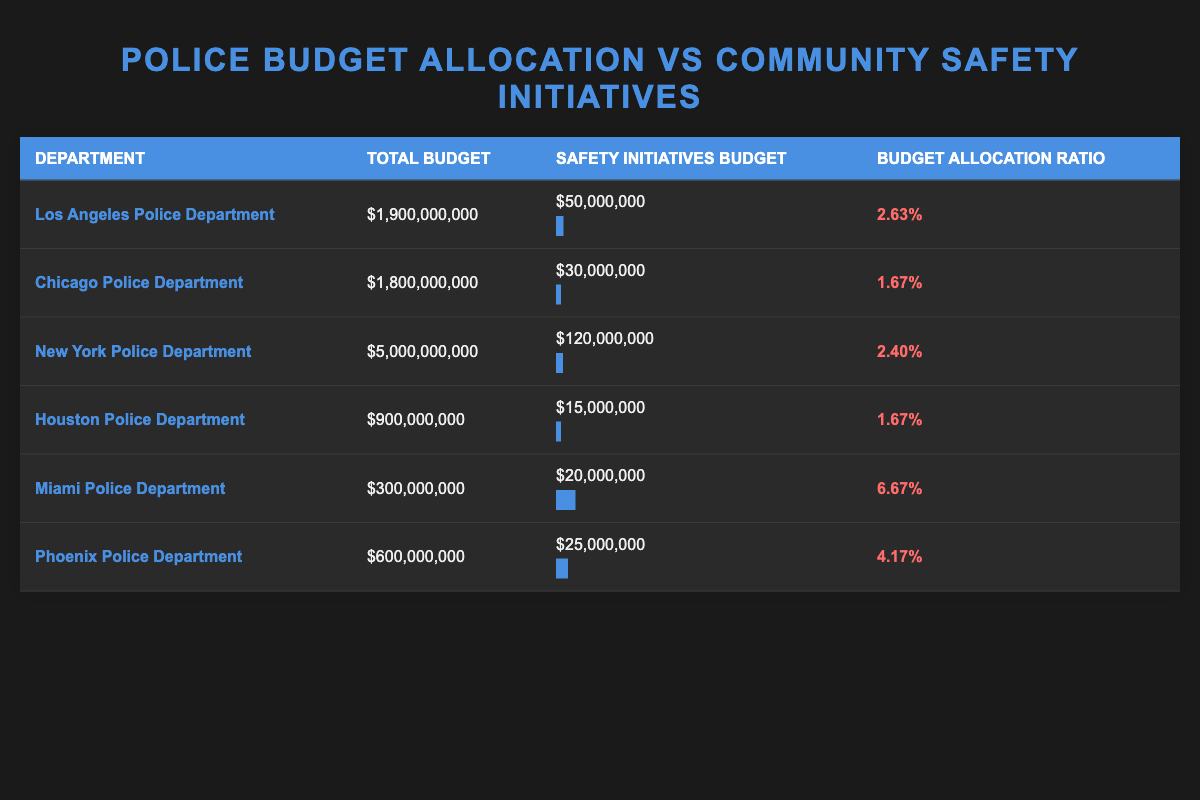What is the total budget for the New York Police Department? The total budget is listed directly in the table under the 'Total Budget' column for the New York Police Department. It shows $5,000,000,000.
Answer: 5,000,000,000 Which police department has the highest budget allocation ratio for safety initiatives? By examining the 'Budget Allocation Ratio' column, the Miami Police Department has the highest value at 6.67%.
Answer: 6.67% Is the safety initiatives budget for the Houston Police Department higher than the Chicago Police Department? Comparing the safety initiatives budget from both departments: Houston has $15,000,000 while Chicago has $30,000,000. Since $15,000,000 is less than $30,000,000, the answer is no.
Answer: No What is the combined total budget for the Los Angeles and Phoenix Police Departments? The total budget for Los Angeles is $1,900,000,000 and for Phoenix it is $600,000,000. Adding these together gives $1,900,000,000 + $600,000,000 = $2,500,000,000.
Answer: 2,500,000,000 Is the budget allocation ratio of the Los Angeles Police Department greater than 2%? The budget allocation ratio for Los Angeles is 2.63%, which is indeed greater than 2%. Thus, the answer is yes.
Answer: Yes What is the average budget allocation ratio across all departments listed? First, sum the budget allocation ratios: 0.0263 + 0.0167 + 0.024 + 0.0167 + 0.0667 + 0.0417 = 0.1931. Then, divide by the number of departments, which is 6: 0.1931 / 6 ≈ 0.0322.
Answer: 0.0322 How much less is the safety initiatives budget for the Chicago Police Department compared to the total budget? The total budget for Chicago is $1,800,000,000 and the safety initiatives budget is $30,000,000. The difference can be calculated as $1,800,000,000 - $30,000,000 = $1,770,000,000.
Answer: 1,770,000,000 Do both the Houston and Miami Police Departments have safety initiatives budgets exceeding $20,000,000? Houston has a safety initiatives budget of $15,000,000 and Miami has $20,000,000. Since Houston's budget does not exceed $20,000,000, the answer is no.
Answer: No Which department has a higher safety initiatives budget, Los Angeles or New York? Los Angeles has a budget of $50,000,000, while New York has $120,000,000. Since $120,000,000 is greater than $50,000,000, New York has a higher safety initiatives budget.
Answer: New York 